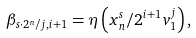Convert formula to latex. <formula><loc_0><loc_0><loc_500><loc_500>\beta _ { s \cdot 2 ^ { n } / j , i + 1 } = \eta \left ( { x _ { n } ^ { s } } / { 2 ^ { i + 1 } v _ { 1 } ^ { j } } \right ) ,</formula> 